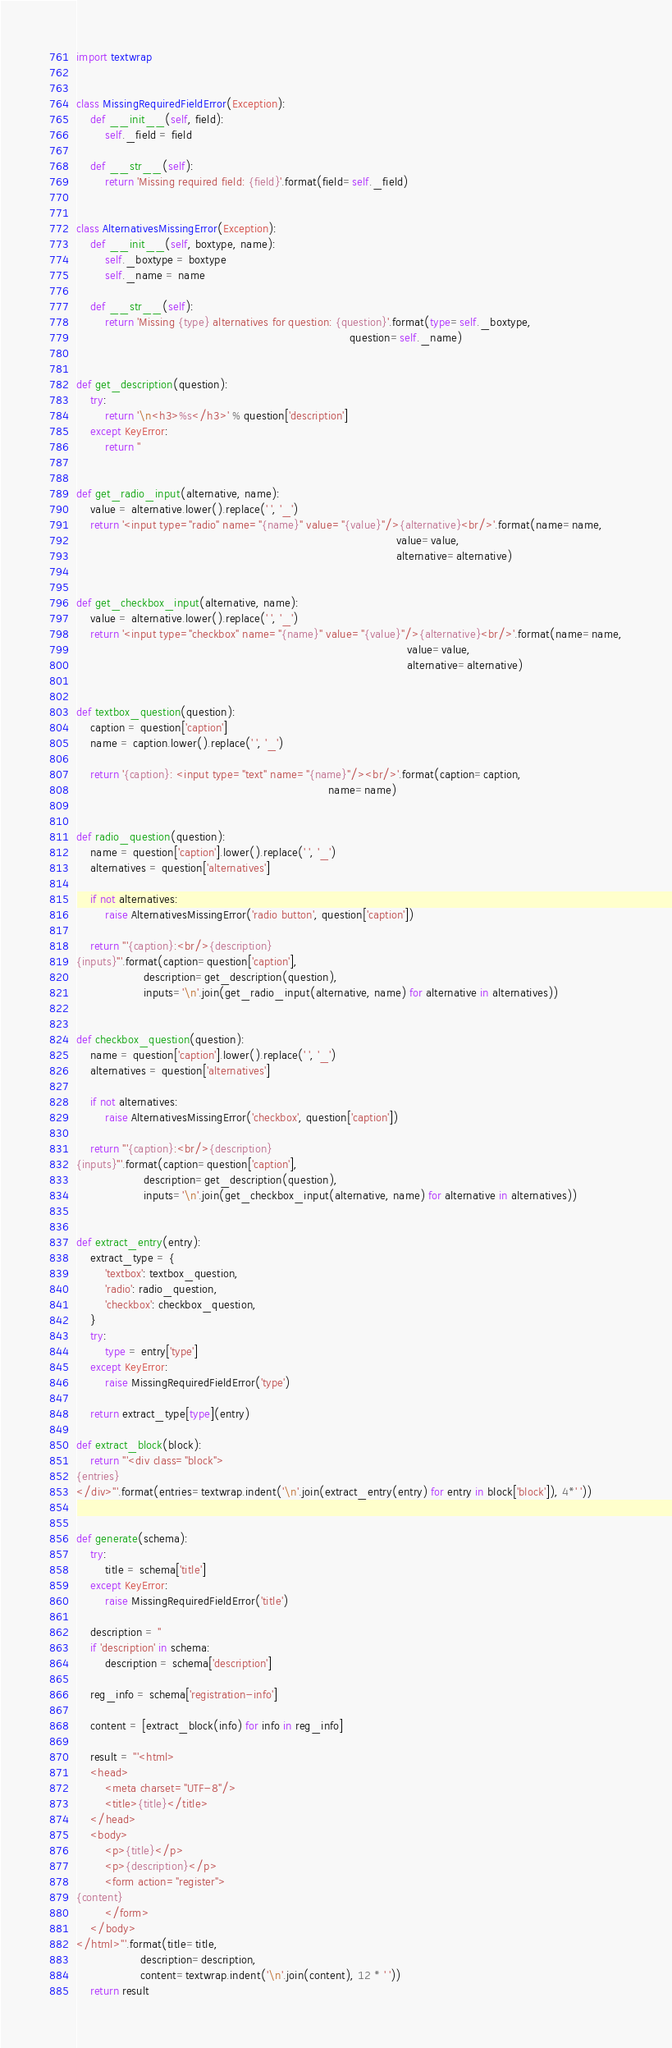<code> <loc_0><loc_0><loc_500><loc_500><_Python_>import textwrap


class MissingRequiredFieldError(Exception):
    def __init__(self, field):
        self._field = field

    def __str__(self):
        return 'Missing required field: {field}'.format(field=self._field)


class AlternativesMissingError(Exception):
    def __init__(self, boxtype, name):
        self._boxtype = boxtype
        self._name = name

    def __str__(self):
        return 'Missing {type} alternatives for question: {question}'.format(type=self._boxtype,
                                                                             question=self._name)


def get_description(question):
    try:
        return '\n<h3>%s</h3>' % question['description']
    except KeyError:
        return ''


def get_radio_input(alternative, name):
    value = alternative.lower().replace(' ', '_')
    return '<input type="radio" name="{name}" value="{value}"/>{alternative}<br/>'.format(name=name,
                                                                                          value=value,
                                                                                          alternative=alternative)


def get_checkbox_input(alternative, name):
    value = alternative.lower().replace(' ', '_')
    return '<input type="checkbox" name="{name}" value="{value}"/>{alternative}<br/>'.format(name=name,
                                                                                             value=value,
                                                                                             alternative=alternative)


def textbox_question(question):
    caption = question['caption']
    name = caption.lower().replace(' ', '_')

    return '{caption}: <input type="text" name="{name}"/><br/>'.format(caption=caption,
                                                                       name=name)


def radio_question(question):
    name = question['caption'].lower().replace(' ', '_')
    alternatives = question['alternatives']

    if not alternatives:
        raise AlternativesMissingError('radio button', question['caption'])

    return '''{caption}:<br/>{description}
{inputs}'''.format(caption=question['caption'],
                   description=get_description(question),
                   inputs='\n'.join(get_radio_input(alternative, name) for alternative in alternatives))


def checkbox_question(question):
    name = question['caption'].lower().replace(' ', '_')
    alternatives = question['alternatives']

    if not alternatives:
        raise AlternativesMissingError('checkbox', question['caption'])

    return '''{caption}:<br/>{description}
{inputs}'''.format(caption=question['caption'],
                   description=get_description(question),
                   inputs='\n'.join(get_checkbox_input(alternative, name) for alternative in alternatives))


def extract_entry(entry):
    extract_type = {
        'textbox': textbox_question,
        'radio': radio_question,
        'checkbox': checkbox_question,
    }
    try:
        type = entry['type']
    except KeyError:
        raise MissingRequiredFieldError('type')

    return extract_type[type](entry)

def extract_block(block):
    return '''<div class="block">
{entries}
</div>'''.format(entries=textwrap.indent('\n'.join(extract_entry(entry) for entry in block['block']), 4*' '))


def generate(schema):
    try:
        title = schema['title']
    except KeyError:
        raise MissingRequiredFieldError('title')

    description = ''
    if 'description' in schema:
        description = schema['description']

    reg_info = schema['registration-info']

    content = [extract_block(info) for info in reg_info]

    result = '''<html>
    <head>
        <meta charset="UTF-8"/>
        <title>{title}</title>
    </head>
    <body>
        <p>{title}</p>
        <p>{description}</p>
        <form action="register">
{content}
        </form>
    </body>
</html>'''.format(title=title,
                  description=description,
                  content=textwrap.indent('\n'.join(content), 12 * ' '))
    return result
</code> 